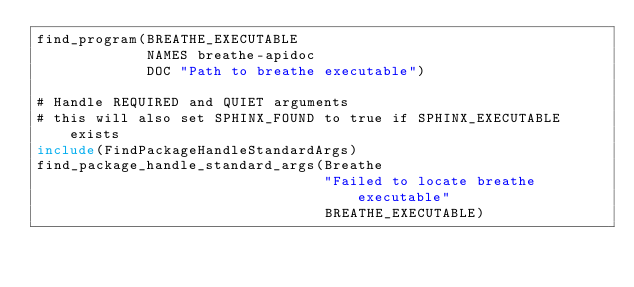<code> <loc_0><loc_0><loc_500><loc_500><_CMake_>find_program(BREATHE_EXECUTABLE
             NAMES breathe-apidoc
             DOC "Path to breathe executable")

# Handle REQUIRED and QUIET arguments
# this will also set SPHINX_FOUND to true if SPHINX_EXECUTABLE exists
include(FindPackageHandleStandardArgs)
find_package_handle_standard_args(Breathe
                                  "Failed to locate breathe executable"
                                  BREATHE_EXECUTABLE)
</code> 